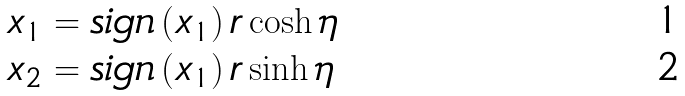<formula> <loc_0><loc_0><loc_500><loc_500>x _ { 1 } & = s i g n \left ( x _ { 1 } \right ) r \cosh { \eta } \\ x _ { 2 } & = s i g n \left ( x _ { 1 } \right ) r \sinh { \eta }</formula> 